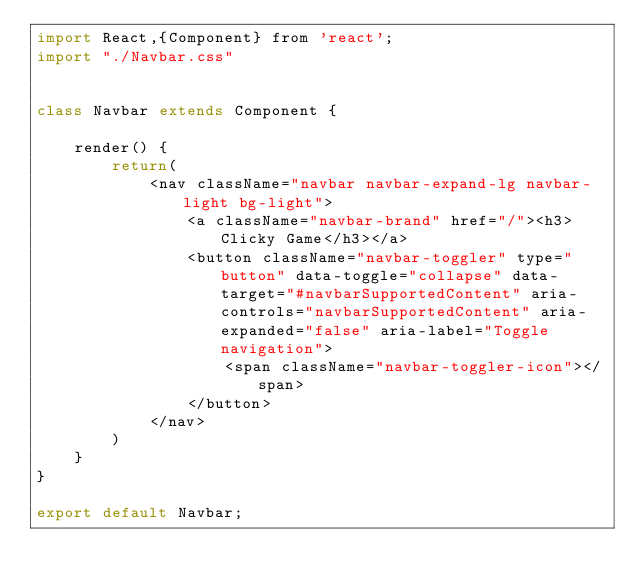Convert code to text. <code><loc_0><loc_0><loc_500><loc_500><_JavaScript_>import React,{Component} from 'react';
import "./Navbar.css"


class Navbar extends Component {

    render() {
        return(
            <nav className="navbar navbar-expand-lg navbar-light bg-light">
                <a className="navbar-brand" href="/"><h3>Clicky Game</h3></a>
                <button className="navbar-toggler" type="button" data-toggle="collapse" data-target="#navbarSupportedContent" aria-controls="navbarSupportedContent" aria-expanded="false" aria-label="Toggle navigation">
                    <span className="navbar-toggler-icon"></span>
                </button>
            </nav>
        )
    }
}

export default Navbar;</code> 